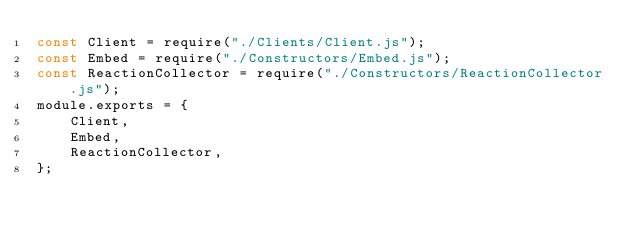Convert code to text. <code><loc_0><loc_0><loc_500><loc_500><_JavaScript_>const Client = require("./Clients/Client.js");
const Embed = require("./Constructors/Embed.js");
const ReactionCollector = require("./Constructors/ReactionCollector.js");
module.exports = {
    Client,
    Embed,
    ReactionCollector,
};
</code> 